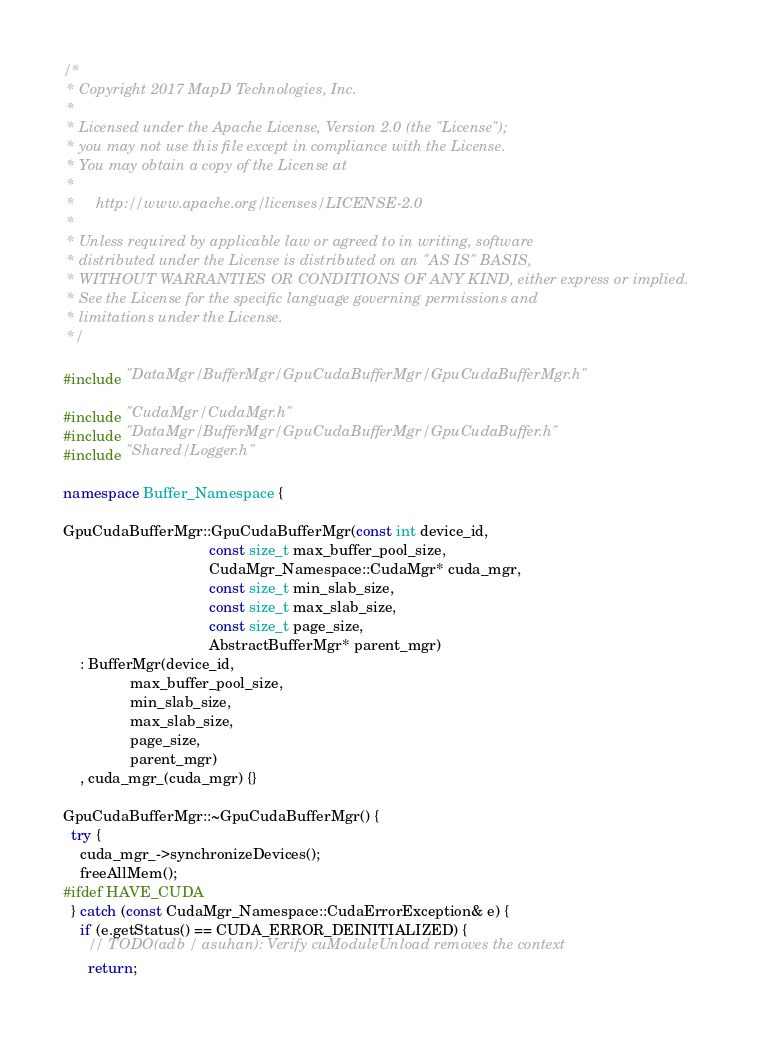<code> <loc_0><loc_0><loc_500><loc_500><_C++_>/*
 * Copyright 2017 MapD Technologies, Inc.
 *
 * Licensed under the Apache License, Version 2.0 (the "License");
 * you may not use this file except in compliance with the License.
 * You may obtain a copy of the License at
 *
 *     http://www.apache.org/licenses/LICENSE-2.0
 *
 * Unless required by applicable law or agreed to in writing, software
 * distributed under the License is distributed on an "AS IS" BASIS,
 * WITHOUT WARRANTIES OR CONDITIONS OF ANY KIND, either express or implied.
 * See the License for the specific language governing permissions and
 * limitations under the License.
 */

#include "DataMgr/BufferMgr/GpuCudaBufferMgr/GpuCudaBufferMgr.h"

#include "CudaMgr/CudaMgr.h"
#include "DataMgr/BufferMgr/GpuCudaBufferMgr/GpuCudaBuffer.h"
#include "Shared/Logger.h"

namespace Buffer_Namespace {

GpuCudaBufferMgr::GpuCudaBufferMgr(const int device_id,
                                   const size_t max_buffer_pool_size,
                                   CudaMgr_Namespace::CudaMgr* cuda_mgr,
                                   const size_t min_slab_size,
                                   const size_t max_slab_size,
                                   const size_t page_size,
                                   AbstractBufferMgr* parent_mgr)
    : BufferMgr(device_id,
                max_buffer_pool_size,
                min_slab_size,
                max_slab_size,
                page_size,
                parent_mgr)
    , cuda_mgr_(cuda_mgr) {}

GpuCudaBufferMgr::~GpuCudaBufferMgr() {
  try {
    cuda_mgr_->synchronizeDevices();
    freeAllMem();
#ifdef HAVE_CUDA
  } catch (const CudaMgr_Namespace::CudaErrorException& e) {
    if (e.getStatus() == CUDA_ERROR_DEINITIALIZED) {
      // TODO(adb / asuhan): Verify cuModuleUnload removes the context
      return;</code> 